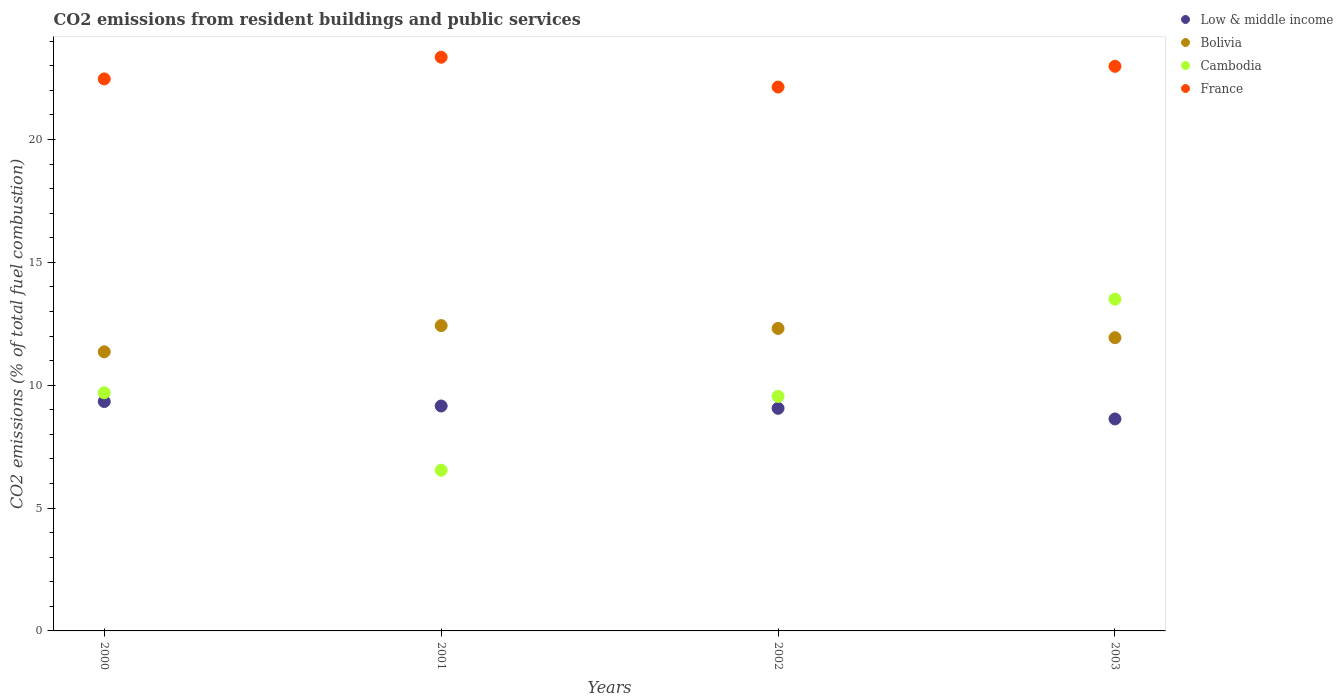What is the total CO2 emitted in Bolivia in 2001?
Your response must be concise. 12.43. Across all years, what is the maximum total CO2 emitted in Low & middle income?
Ensure brevity in your answer.  9.34. Across all years, what is the minimum total CO2 emitted in Bolivia?
Your answer should be very brief. 11.36. What is the total total CO2 emitted in Low & middle income in the graph?
Provide a succinct answer. 36.18. What is the difference between the total CO2 emitted in Bolivia in 2001 and that in 2002?
Provide a succinct answer. 0.11. What is the difference between the total CO2 emitted in Low & middle income in 2000 and the total CO2 emitted in France in 2001?
Ensure brevity in your answer.  -14.01. What is the average total CO2 emitted in Cambodia per year?
Give a very brief answer. 9.82. In the year 2003, what is the difference between the total CO2 emitted in Cambodia and total CO2 emitted in Low & middle income?
Offer a very short reply. 4.87. What is the ratio of the total CO2 emitted in Low & middle income in 2000 to that in 2002?
Your response must be concise. 1.03. Is the total CO2 emitted in Cambodia in 2001 less than that in 2002?
Make the answer very short. Yes. Is the difference between the total CO2 emitted in Cambodia in 2002 and 2003 greater than the difference between the total CO2 emitted in Low & middle income in 2002 and 2003?
Give a very brief answer. No. What is the difference between the highest and the second highest total CO2 emitted in Low & middle income?
Keep it short and to the point. 0.18. What is the difference between the highest and the lowest total CO2 emitted in Bolivia?
Ensure brevity in your answer.  1.07. Is the sum of the total CO2 emitted in France in 2000 and 2001 greater than the maximum total CO2 emitted in Cambodia across all years?
Offer a terse response. Yes. Is the total CO2 emitted in Bolivia strictly greater than the total CO2 emitted in Low & middle income over the years?
Provide a short and direct response. Yes. How many dotlines are there?
Your answer should be very brief. 4. How many years are there in the graph?
Make the answer very short. 4. Are the values on the major ticks of Y-axis written in scientific E-notation?
Keep it short and to the point. No. Does the graph contain any zero values?
Give a very brief answer. No. Where does the legend appear in the graph?
Offer a terse response. Top right. How many legend labels are there?
Your response must be concise. 4. How are the legend labels stacked?
Your answer should be compact. Vertical. What is the title of the graph?
Your answer should be compact. CO2 emissions from resident buildings and public services. What is the label or title of the Y-axis?
Provide a succinct answer. CO2 emissions (% of total fuel combustion). What is the CO2 emissions (% of total fuel combustion) of Low & middle income in 2000?
Offer a terse response. 9.34. What is the CO2 emissions (% of total fuel combustion) of Bolivia in 2000?
Your response must be concise. 11.36. What is the CO2 emissions (% of total fuel combustion) in Cambodia in 2000?
Your answer should be very brief. 9.69. What is the CO2 emissions (% of total fuel combustion) in France in 2000?
Your answer should be compact. 22.47. What is the CO2 emissions (% of total fuel combustion) of Low & middle income in 2001?
Offer a terse response. 9.15. What is the CO2 emissions (% of total fuel combustion) of Bolivia in 2001?
Your response must be concise. 12.43. What is the CO2 emissions (% of total fuel combustion) in Cambodia in 2001?
Your answer should be very brief. 6.54. What is the CO2 emissions (% of total fuel combustion) of France in 2001?
Ensure brevity in your answer.  23.35. What is the CO2 emissions (% of total fuel combustion) of Low & middle income in 2002?
Provide a short and direct response. 9.06. What is the CO2 emissions (% of total fuel combustion) in Bolivia in 2002?
Provide a short and direct response. 12.31. What is the CO2 emissions (% of total fuel combustion) in Cambodia in 2002?
Offer a terse response. 9.55. What is the CO2 emissions (% of total fuel combustion) in France in 2002?
Your answer should be very brief. 22.14. What is the CO2 emissions (% of total fuel combustion) of Low & middle income in 2003?
Keep it short and to the point. 8.63. What is the CO2 emissions (% of total fuel combustion) in Bolivia in 2003?
Your answer should be compact. 11.93. What is the CO2 emissions (% of total fuel combustion) of Cambodia in 2003?
Offer a terse response. 13.5. What is the CO2 emissions (% of total fuel combustion) of France in 2003?
Give a very brief answer. 22.98. Across all years, what is the maximum CO2 emissions (% of total fuel combustion) in Low & middle income?
Keep it short and to the point. 9.34. Across all years, what is the maximum CO2 emissions (% of total fuel combustion) in Bolivia?
Make the answer very short. 12.43. Across all years, what is the maximum CO2 emissions (% of total fuel combustion) of Cambodia?
Offer a very short reply. 13.5. Across all years, what is the maximum CO2 emissions (% of total fuel combustion) in France?
Your answer should be compact. 23.35. Across all years, what is the minimum CO2 emissions (% of total fuel combustion) of Low & middle income?
Provide a succinct answer. 8.63. Across all years, what is the minimum CO2 emissions (% of total fuel combustion) of Bolivia?
Your response must be concise. 11.36. Across all years, what is the minimum CO2 emissions (% of total fuel combustion) of Cambodia?
Ensure brevity in your answer.  6.54. Across all years, what is the minimum CO2 emissions (% of total fuel combustion) in France?
Your response must be concise. 22.14. What is the total CO2 emissions (% of total fuel combustion) in Low & middle income in the graph?
Offer a terse response. 36.18. What is the total CO2 emissions (% of total fuel combustion) of Bolivia in the graph?
Provide a short and direct response. 48.03. What is the total CO2 emissions (% of total fuel combustion) of Cambodia in the graph?
Ensure brevity in your answer.  39.28. What is the total CO2 emissions (% of total fuel combustion) in France in the graph?
Give a very brief answer. 90.93. What is the difference between the CO2 emissions (% of total fuel combustion) in Low & middle income in 2000 and that in 2001?
Offer a very short reply. 0.18. What is the difference between the CO2 emissions (% of total fuel combustion) in Bolivia in 2000 and that in 2001?
Keep it short and to the point. -1.07. What is the difference between the CO2 emissions (% of total fuel combustion) of Cambodia in 2000 and that in 2001?
Ensure brevity in your answer.  3.15. What is the difference between the CO2 emissions (% of total fuel combustion) of France in 2000 and that in 2001?
Your response must be concise. -0.88. What is the difference between the CO2 emissions (% of total fuel combustion) in Low & middle income in 2000 and that in 2002?
Give a very brief answer. 0.28. What is the difference between the CO2 emissions (% of total fuel combustion) of Bolivia in 2000 and that in 2002?
Give a very brief answer. -0.95. What is the difference between the CO2 emissions (% of total fuel combustion) of Cambodia in 2000 and that in 2002?
Give a very brief answer. 0.15. What is the difference between the CO2 emissions (% of total fuel combustion) of France in 2000 and that in 2002?
Offer a terse response. 0.33. What is the difference between the CO2 emissions (% of total fuel combustion) in Low & middle income in 2000 and that in 2003?
Your response must be concise. 0.71. What is the difference between the CO2 emissions (% of total fuel combustion) of Bolivia in 2000 and that in 2003?
Ensure brevity in your answer.  -0.57. What is the difference between the CO2 emissions (% of total fuel combustion) in Cambodia in 2000 and that in 2003?
Ensure brevity in your answer.  -3.81. What is the difference between the CO2 emissions (% of total fuel combustion) of France in 2000 and that in 2003?
Provide a short and direct response. -0.51. What is the difference between the CO2 emissions (% of total fuel combustion) of Low & middle income in 2001 and that in 2002?
Give a very brief answer. 0.09. What is the difference between the CO2 emissions (% of total fuel combustion) of Bolivia in 2001 and that in 2002?
Your answer should be compact. 0.12. What is the difference between the CO2 emissions (% of total fuel combustion) in Cambodia in 2001 and that in 2002?
Make the answer very short. -3. What is the difference between the CO2 emissions (% of total fuel combustion) in France in 2001 and that in 2002?
Your answer should be compact. 1.21. What is the difference between the CO2 emissions (% of total fuel combustion) in Low & middle income in 2001 and that in 2003?
Keep it short and to the point. 0.53. What is the difference between the CO2 emissions (% of total fuel combustion) of Bolivia in 2001 and that in 2003?
Provide a succinct answer. 0.49. What is the difference between the CO2 emissions (% of total fuel combustion) in Cambodia in 2001 and that in 2003?
Offer a terse response. -6.96. What is the difference between the CO2 emissions (% of total fuel combustion) of France in 2001 and that in 2003?
Offer a very short reply. 0.37. What is the difference between the CO2 emissions (% of total fuel combustion) in Low & middle income in 2002 and that in 2003?
Make the answer very short. 0.43. What is the difference between the CO2 emissions (% of total fuel combustion) of Bolivia in 2002 and that in 2003?
Provide a succinct answer. 0.38. What is the difference between the CO2 emissions (% of total fuel combustion) in Cambodia in 2002 and that in 2003?
Offer a very short reply. -3.96. What is the difference between the CO2 emissions (% of total fuel combustion) in France in 2002 and that in 2003?
Offer a very short reply. -0.84. What is the difference between the CO2 emissions (% of total fuel combustion) in Low & middle income in 2000 and the CO2 emissions (% of total fuel combustion) in Bolivia in 2001?
Make the answer very short. -3.09. What is the difference between the CO2 emissions (% of total fuel combustion) in Low & middle income in 2000 and the CO2 emissions (% of total fuel combustion) in Cambodia in 2001?
Provide a short and direct response. 2.8. What is the difference between the CO2 emissions (% of total fuel combustion) in Low & middle income in 2000 and the CO2 emissions (% of total fuel combustion) in France in 2001?
Provide a succinct answer. -14.01. What is the difference between the CO2 emissions (% of total fuel combustion) of Bolivia in 2000 and the CO2 emissions (% of total fuel combustion) of Cambodia in 2001?
Your answer should be compact. 4.82. What is the difference between the CO2 emissions (% of total fuel combustion) in Bolivia in 2000 and the CO2 emissions (% of total fuel combustion) in France in 2001?
Provide a short and direct response. -11.99. What is the difference between the CO2 emissions (% of total fuel combustion) of Cambodia in 2000 and the CO2 emissions (% of total fuel combustion) of France in 2001?
Offer a very short reply. -13.66. What is the difference between the CO2 emissions (% of total fuel combustion) of Low & middle income in 2000 and the CO2 emissions (% of total fuel combustion) of Bolivia in 2002?
Provide a succinct answer. -2.97. What is the difference between the CO2 emissions (% of total fuel combustion) of Low & middle income in 2000 and the CO2 emissions (% of total fuel combustion) of Cambodia in 2002?
Give a very brief answer. -0.21. What is the difference between the CO2 emissions (% of total fuel combustion) of Low & middle income in 2000 and the CO2 emissions (% of total fuel combustion) of France in 2002?
Ensure brevity in your answer.  -12.8. What is the difference between the CO2 emissions (% of total fuel combustion) in Bolivia in 2000 and the CO2 emissions (% of total fuel combustion) in Cambodia in 2002?
Ensure brevity in your answer.  1.81. What is the difference between the CO2 emissions (% of total fuel combustion) in Bolivia in 2000 and the CO2 emissions (% of total fuel combustion) in France in 2002?
Provide a succinct answer. -10.78. What is the difference between the CO2 emissions (% of total fuel combustion) of Cambodia in 2000 and the CO2 emissions (% of total fuel combustion) of France in 2002?
Keep it short and to the point. -12.44. What is the difference between the CO2 emissions (% of total fuel combustion) in Low & middle income in 2000 and the CO2 emissions (% of total fuel combustion) in Bolivia in 2003?
Make the answer very short. -2.6. What is the difference between the CO2 emissions (% of total fuel combustion) of Low & middle income in 2000 and the CO2 emissions (% of total fuel combustion) of Cambodia in 2003?
Give a very brief answer. -4.16. What is the difference between the CO2 emissions (% of total fuel combustion) in Low & middle income in 2000 and the CO2 emissions (% of total fuel combustion) in France in 2003?
Provide a succinct answer. -13.64. What is the difference between the CO2 emissions (% of total fuel combustion) in Bolivia in 2000 and the CO2 emissions (% of total fuel combustion) in Cambodia in 2003?
Provide a succinct answer. -2.14. What is the difference between the CO2 emissions (% of total fuel combustion) of Bolivia in 2000 and the CO2 emissions (% of total fuel combustion) of France in 2003?
Offer a very short reply. -11.62. What is the difference between the CO2 emissions (% of total fuel combustion) of Cambodia in 2000 and the CO2 emissions (% of total fuel combustion) of France in 2003?
Provide a short and direct response. -13.29. What is the difference between the CO2 emissions (% of total fuel combustion) of Low & middle income in 2001 and the CO2 emissions (% of total fuel combustion) of Bolivia in 2002?
Your answer should be very brief. -3.16. What is the difference between the CO2 emissions (% of total fuel combustion) of Low & middle income in 2001 and the CO2 emissions (% of total fuel combustion) of Cambodia in 2002?
Offer a terse response. -0.39. What is the difference between the CO2 emissions (% of total fuel combustion) of Low & middle income in 2001 and the CO2 emissions (% of total fuel combustion) of France in 2002?
Offer a very short reply. -12.98. What is the difference between the CO2 emissions (% of total fuel combustion) of Bolivia in 2001 and the CO2 emissions (% of total fuel combustion) of Cambodia in 2002?
Provide a succinct answer. 2.88. What is the difference between the CO2 emissions (% of total fuel combustion) of Bolivia in 2001 and the CO2 emissions (% of total fuel combustion) of France in 2002?
Offer a terse response. -9.71. What is the difference between the CO2 emissions (% of total fuel combustion) in Cambodia in 2001 and the CO2 emissions (% of total fuel combustion) in France in 2002?
Make the answer very short. -15.59. What is the difference between the CO2 emissions (% of total fuel combustion) in Low & middle income in 2001 and the CO2 emissions (% of total fuel combustion) in Bolivia in 2003?
Your answer should be compact. -2.78. What is the difference between the CO2 emissions (% of total fuel combustion) of Low & middle income in 2001 and the CO2 emissions (% of total fuel combustion) of Cambodia in 2003?
Ensure brevity in your answer.  -4.35. What is the difference between the CO2 emissions (% of total fuel combustion) in Low & middle income in 2001 and the CO2 emissions (% of total fuel combustion) in France in 2003?
Your answer should be compact. -13.83. What is the difference between the CO2 emissions (% of total fuel combustion) in Bolivia in 2001 and the CO2 emissions (% of total fuel combustion) in Cambodia in 2003?
Offer a very short reply. -1.08. What is the difference between the CO2 emissions (% of total fuel combustion) in Bolivia in 2001 and the CO2 emissions (% of total fuel combustion) in France in 2003?
Keep it short and to the point. -10.55. What is the difference between the CO2 emissions (% of total fuel combustion) of Cambodia in 2001 and the CO2 emissions (% of total fuel combustion) of France in 2003?
Provide a succinct answer. -16.44. What is the difference between the CO2 emissions (% of total fuel combustion) in Low & middle income in 2002 and the CO2 emissions (% of total fuel combustion) in Bolivia in 2003?
Make the answer very short. -2.87. What is the difference between the CO2 emissions (% of total fuel combustion) of Low & middle income in 2002 and the CO2 emissions (% of total fuel combustion) of Cambodia in 2003?
Give a very brief answer. -4.44. What is the difference between the CO2 emissions (% of total fuel combustion) in Low & middle income in 2002 and the CO2 emissions (% of total fuel combustion) in France in 2003?
Make the answer very short. -13.92. What is the difference between the CO2 emissions (% of total fuel combustion) in Bolivia in 2002 and the CO2 emissions (% of total fuel combustion) in Cambodia in 2003?
Offer a very short reply. -1.19. What is the difference between the CO2 emissions (% of total fuel combustion) in Bolivia in 2002 and the CO2 emissions (% of total fuel combustion) in France in 2003?
Give a very brief answer. -10.67. What is the difference between the CO2 emissions (% of total fuel combustion) in Cambodia in 2002 and the CO2 emissions (% of total fuel combustion) in France in 2003?
Your answer should be very brief. -13.44. What is the average CO2 emissions (% of total fuel combustion) in Low & middle income per year?
Your answer should be very brief. 9.05. What is the average CO2 emissions (% of total fuel combustion) in Bolivia per year?
Give a very brief answer. 12.01. What is the average CO2 emissions (% of total fuel combustion) in Cambodia per year?
Your answer should be compact. 9.82. What is the average CO2 emissions (% of total fuel combustion) of France per year?
Offer a very short reply. 22.73. In the year 2000, what is the difference between the CO2 emissions (% of total fuel combustion) of Low & middle income and CO2 emissions (% of total fuel combustion) of Bolivia?
Your answer should be very brief. -2.02. In the year 2000, what is the difference between the CO2 emissions (% of total fuel combustion) of Low & middle income and CO2 emissions (% of total fuel combustion) of Cambodia?
Your answer should be compact. -0.36. In the year 2000, what is the difference between the CO2 emissions (% of total fuel combustion) of Low & middle income and CO2 emissions (% of total fuel combustion) of France?
Give a very brief answer. -13.13. In the year 2000, what is the difference between the CO2 emissions (% of total fuel combustion) in Bolivia and CO2 emissions (% of total fuel combustion) in Cambodia?
Ensure brevity in your answer.  1.67. In the year 2000, what is the difference between the CO2 emissions (% of total fuel combustion) of Bolivia and CO2 emissions (% of total fuel combustion) of France?
Provide a succinct answer. -11.11. In the year 2000, what is the difference between the CO2 emissions (% of total fuel combustion) in Cambodia and CO2 emissions (% of total fuel combustion) in France?
Provide a short and direct response. -12.77. In the year 2001, what is the difference between the CO2 emissions (% of total fuel combustion) of Low & middle income and CO2 emissions (% of total fuel combustion) of Bolivia?
Your answer should be very brief. -3.27. In the year 2001, what is the difference between the CO2 emissions (% of total fuel combustion) in Low & middle income and CO2 emissions (% of total fuel combustion) in Cambodia?
Provide a succinct answer. 2.61. In the year 2001, what is the difference between the CO2 emissions (% of total fuel combustion) in Low & middle income and CO2 emissions (% of total fuel combustion) in France?
Offer a terse response. -14.2. In the year 2001, what is the difference between the CO2 emissions (% of total fuel combustion) of Bolivia and CO2 emissions (% of total fuel combustion) of Cambodia?
Your answer should be compact. 5.88. In the year 2001, what is the difference between the CO2 emissions (% of total fuel combustion) of Bolivia and CO2 emissions (% of total fuel combustion) of France?
Offer a terse response. -10.92. In the year 2001, what is the difference between the CO2 emissions (% of total fuel combustion) of Cambodia and CO2 emissions (% of total fuel combustion) of France?
Ensure brevity in your answer.  -16.81. In the year 2002, what is the difference between the CO2 emissions (% of total fuel combustion) in Low & middle income and CO2 emissions (% of total fuel combustion) in Bolivia?
Provide a short and direct response. -3.25. In the year 2002, what is the difference between the CO2 emissions (% of total fuel combustion) in Low & middle income and CO2 emissions (% of total fuel combustion) in Cambodia?
Ensure brevity in your answer.  -0.49. In the year 2002, what is the difference between the CO2 emissions (% of total fuel combustion) of Low & middle income and CO2 emissions (% of total fuel combustion) of France?
Your answer should be compact. -13.08. In the year 2002, what is the difference between the CO2 emissions (% of total fuel combustion) in Bolivia and CO2 emissions (% of total fuel combustion) in Cambodia?
Your answer should be compact. 2.77. In the year 2002, what is the difference between the CO2 emissions (% of total fuel combustion) in Bolivia and CO2 emissions (% of total fuel combustion) in France?
Your response must be concise. -9.82. In the year 2002, what is the difference between the CO2 emissions (% of total fuel combustion) in Cambodia and CO2 emissions (% of total fuel combustion) in France?
Provide a succinct answer. -12.59. In the year 2003, what is the difference between the CO2 emissions (% of total fuel combustion) of Low & middle income and CO2 emissions (% of total fuel combustion) of Bolivia?
Make the answer very short. -3.31. In the year 2003, what is the difference between the CO2 emissions (% of total fuel combustion) in Low & middle income and CO2 emissions (% of total fuel combustion) in Cambodia?
Provide a succinct answer. -4.87. In the year 2003, what is the difference between the CO2 emissions (% of total fuel combustion) of Low & middle income and CO2 emissions (% of total fuel combustion) of France?
Provide a succinct answer. -14.35. In the year 2003, what is the difference between the CO2 emissions (% of total fuel combustion) in Bolivia and CO2 emissions (% of total fuel combustion) in Cambodia?
Provide a short and direct response. -1.57. In the year 2003, what is the difference between the CO2 emissions (% of total fuel combustion) of Bolivia and CO2 emissions (% of total fuel combustion) of France?
Provide a succinct answer. -11.05. In the year 2003, what is the difference between the CO2 emissions (% of total fuel combustion) in Cambodia and CO2 emissions (% of total fuel combustion) in France?
Give a very brief answer. -9.48. What is the ratio of the CO2 emissions (% of total fuel combustion) of Low & middle income in 2000 to that in 2001?
Offer a very short reply. 1.02. What is the ratio of the CO2 emissions (% of total fuel combustion) of Bolivia in 2000 to that in 2001?
Provide a short and direct response. 0.91. What is the ratio of the CO2 emissions (% of total fuel combustion) in Cambodia in 2000 to that in 2001?
Keep it short and to the point. 1.48. What is the ratio of the CO2 emissions (% of total fuel combustion) of France in 2000 to that in 2001?
Ensure brevity in your answer.  0.96. What is the ratio of the CO2 emissions (% of total fuel combustion) in Low & middle income in 2000 to that in 2002?
Offer a terse response. 1.03. What is the ratio of the CO2 emissions (% of total fuel combustion) in Bolivia in 2000 to that in 2002?
Keep it short and to the point. 0.92. What is the ratio of the CO2 emissions (% of total fuel combustion) of Cambodia in 2000 to that in 2002?
Make the answer very short. 1.02. What is the ratio of the CO2 emissions (% of total fuel combustion) in France in 2000 to that in 2002?
Offer a very short reply. 1.01. What is the ratio of the CO2 emissions (% of total fuel combustion) in Low & middle income in 2000 to that in 2003?
Make the answer very short. 1.08. What is the ratio of the CO2 emissions (% of total fuel combustion) of Bolivia in 2000 to that in 2003?
Provide a short and direct response. 0.95. What is the ratio of the CO2 emissions (% of total fuel combustion) of Cambodia in 2000 to that in 2003?
Provide a succinct answer. 0.72. What is the ratio of the CO2 emissions (% of total fuel combustion) of France in 2000 to that in 2003?
Provide a succinct answer. 0.98. What is the ratio of the CO2 emissions (% of total fuel combustion) of Low & middle income in 2001 to that in 2002?
Ensure brevity in your answer.  1.01. What is the ratio of the CO2 emissions (% of total fuel combustion) in Bolivia in 2001 to that in 2002?
Keep it short and to the point. 1.01. What is the ratio of the CO2 emissions (% of total fuel combustion) in Cambodia in 2001 to that in 2002?
Your response must be concise. 0.69. What is the ratio of the CO2 emissions (% of total fuel combustion) in France in 2001 to that in 2002?
Provide a succinct answer. 1.05. What is the ratio of the CO2 emissions (% of total fuel combustion) in Low & middle income in 2001 to that in 2003?
Offer a terse response. 1.06. What is the ratio of the CO2 emissions (% of total fuel combustion) of Bolivia in 2001 to that in 2003?
Keep it short and to the point. 1.04. What is the ratio of the CO2 emissions (% of total fuel combustion) of Cambodia in 2001 to that in 2003?
Offer a very short reply. 0.48. What is the ratio of the CO2 emissions (% of total fuel combustion) of France in 2001 to that in 2003?
Ensure brevity in your answer.  1.02. What is the ratio of the CO2 emissions (% of total fuel combustion) of Low & middle income in 2002 to that in 2003?
Offer a very short reply. 1.05. What is the ratio of the CO2 emissions (% of total fuel combustion) of Bolivia in 2002 to that in 2003?
Give a very brief answer. 1.03. What is the ratio of the CO2 emissions (% of total fuel combustion) of Cambodia in 2002 to that in 2003?
Your response must be concise. 0.71. What is the ratio of the CO2 emissions (% of total fuel combustion) of France in 2002 to that in 2003?
Ensure brevity in your answer.  0.96. What is the difference between the highest and the second highest CO2 emissions (% of total fuel combustion) in Low & middle income?
Provide a succinct answer. 0.18. What is the difference between the highest and the second highest CO2 emissions (% of total fuel combustion) in Bolivia?
Provide a short and direct response. 0.12. What is the difference between the highest and the second highest CO2 emissions (% of total fuel combustion) in Cambodia?
Your answer should be very brief. 3.81. What is the difference between the highest and the second highest CO2 emissions (% of total fuel combustion) of France?
Offer a terse response. 0.37. What is the difference between the highest and the lowest CO2 emissions (% of total fuel combustion) in Low & middle income?
Your response must be concise. 0.71. What is the difference between the highest and the lowest CO2 emissions (% of total fuel combustion) of Bolivia?
Ensure brevity in your answer.  1.07. What is the difference between the highest and the lowest CO2 emissions (% of total fuel combustion) of Cambodia?
Offer a very short reply. 6.96. What is the difference between the highest and the lowest CO2 emissions (% of total fuel combustion) of France?
Your response must be concise. 1.21. 